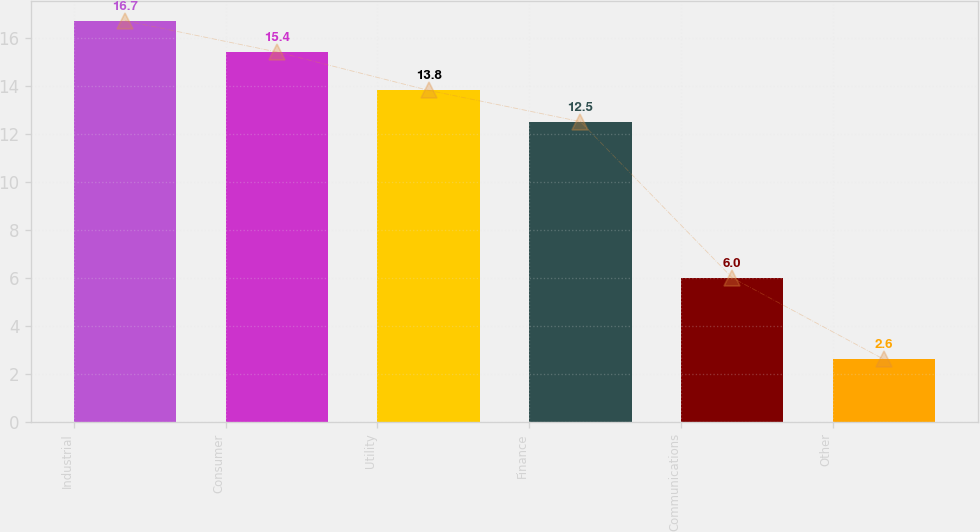<chart> <loc_0><loc_0><loc_500><loc_500><bar_chart><fcel>Industrial<fcel>Consumer<fcel>Utility<fcel>Finance<fcel>Communications<fcel>Other<nl><fcel>16.7<fcel>15.4<fcel>13.8<fcel>12.5<fcel>6<fcel>2.6<nl></chart> 